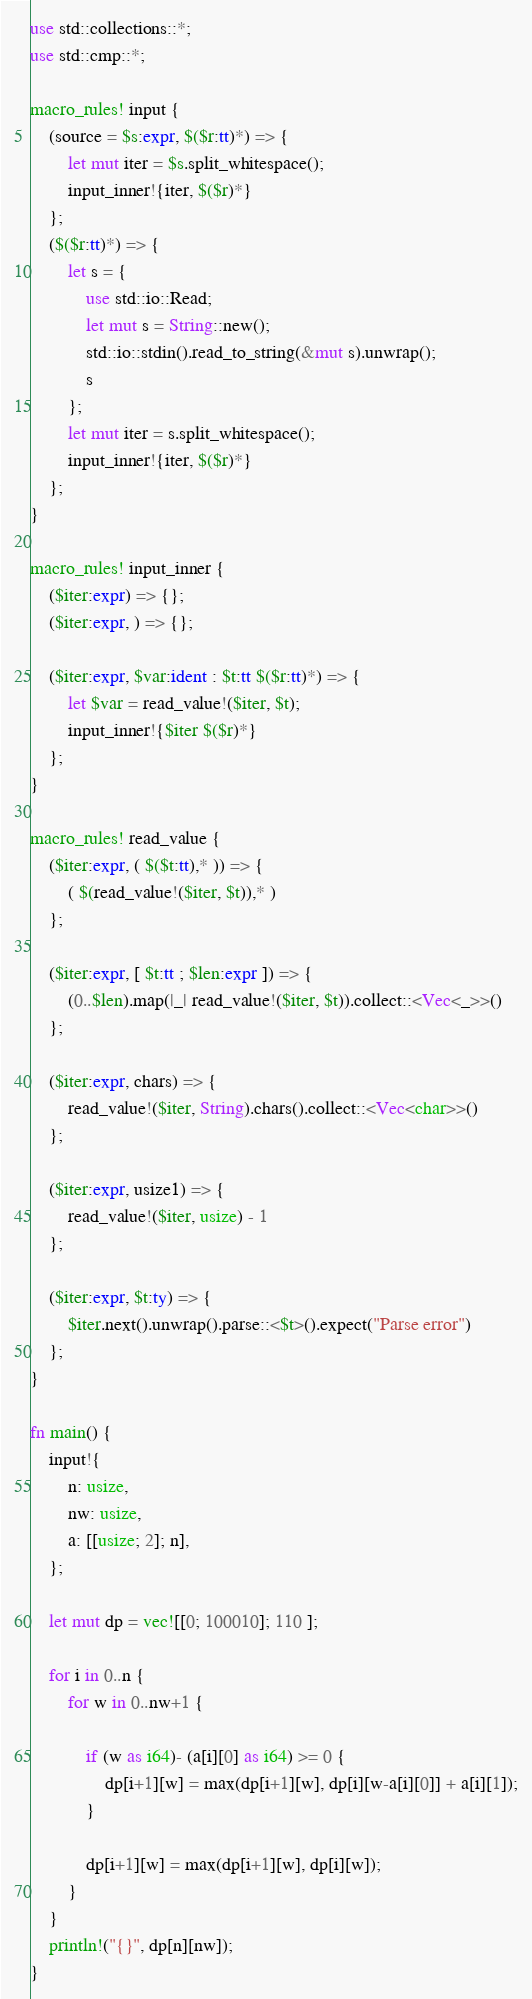<code> <loc_0><loc_0><loc_500><loc_500><_Rust_>use std::collections::*;
use std::cmp::*;

macro_rules! input {
    (source = $s:expr, $($r:tt)*) => {
        let mut iter = $s.split_whitespace();
        input_inner!{iter, $($r)*}
    };
    ($($r:tt)*) => {
        let s = {
            use std::io::Read;
            let mut s = String::new();
            std::io::stdin().read_to_string(&mut s).unwrap();
            s
        };
        let mut iter = s.split_whitespace();
        input_inner!{iter, $($r)*}
    };
}

macro_rules! input_inner {
    ($iter:expr) => {};
    ($iter:expr, ) => {};

    ($iter:expr, $var:ident : $t:tt $($r:tt)*) => {
        let $var = read_value!($iter, $t);
        input_inner!{$iter $($r)*}
    };
}

macro_rules! read_value {
    ($iter:expr, ( $($t:tt),* )) => {
        ( $(read_value!($iter, $t)),* )
    };

    ($iter:expr, [ $t:tt ; $len:expr ]) => {
        (0..$len).map(|_| read_value!($iter, $t)).collect::<Vec<_>>()
    };

    ($iter:expr, chars) => {
        read_value!($iter, String).chars().collect::<Vec<char>>()
    };

    ($iter:expr, usize1) => {
        read_value!($iter, usize) - 1
    };

    ($iter:expr, $t:ty) => {
        $iter.next().unwrap().parse::<$t>().expect("Parse error")
    };
}

fn main() {
    input!{
        n: usize,
        nw: usize,
        a: [[usize; 2]; n],
    };

    let mut dp = vec![[0; 100010]; 110 ];

    for i in 0..n {
        for w in 0..nw+1 {

            if (w as i64)- (a[i][0] as i64) >= 0 {
                dp[i+1][w] = max(dp[i+1][w], dp[i][w-a[i][0]] + a[i][1]);
            } 

            dp[i+1][w] = max(dp[i+1][w], dp[i][w]);
        }
    }
    println!("{}", dp[n][nw]);
}
</code> 